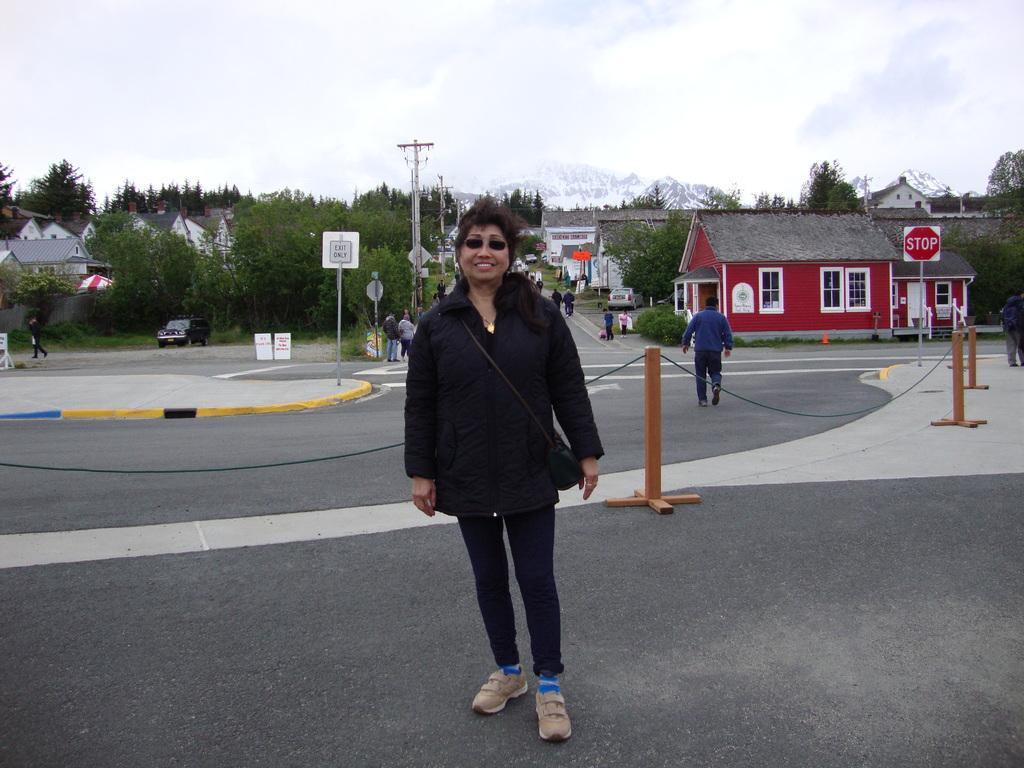How would you summarize this image in a sentence or two? In this image I can see some people on the road. I can see the boards with some text written on it. I can see the vehicles. On the left and right side, I can see the trees and the houses. In the background, I can see the hills and the clouds in the sky. 